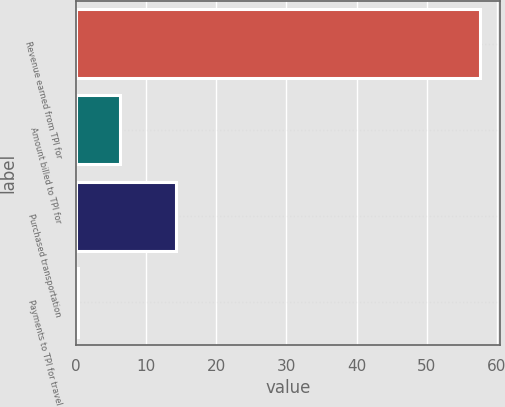Convert chart to OTSL. <chart><loc_0><loc_0><loc_500><loc_500><bar_chart><fcel>Revenue earned from TPI for<fcel>Amount billed to TPI for<fcel>Purchased transportation<fcel>Payments to TPI for travel<nl><fcel>57.6<fcel>6.3<fcel>14.3<fcel>0.3<nl></chart> 